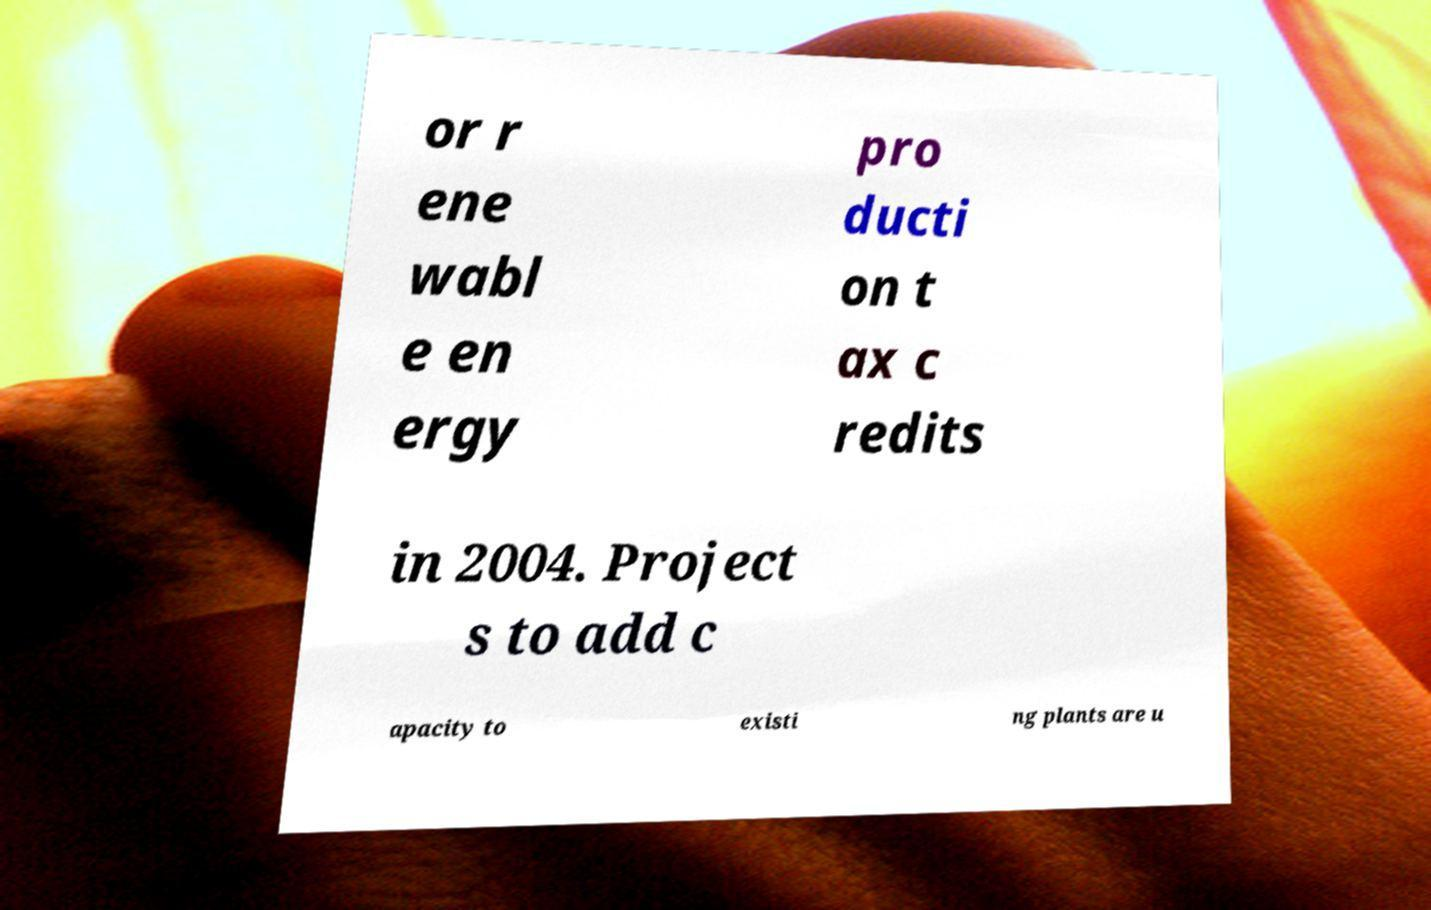Please read and relay the text visible in this image. What does it say? or r ene wabl e en ergy pro ducti on t ax c redits in 2004. Project s to add c apacity to existi ng plants are u 